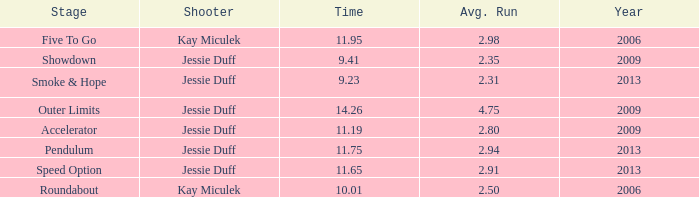What is the sum of years where the average runs are below 4.75 and the time is 14.26? 0.0. 